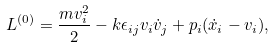Convert formula to latex. <formula><loc_0><loc_0><loc_500><loc_500>L ^ { ( 0 ) } = \frac { m v _ { i } ^ { 2 } } { 2 } - k \epsilon _ { i j } v _ { i } \dot { v } _ { j } + p _ { i } ( \dot { x } _ { i } - v _ { i } ) ,</formula> 